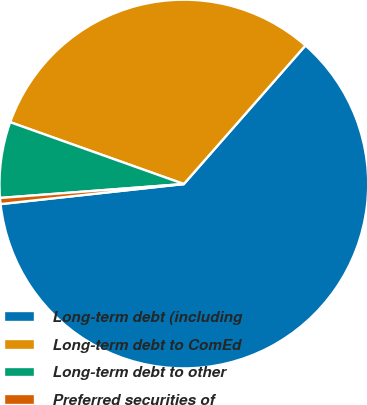Convert chart. <chart><loc_0><loc_0><loc_500><loc_500><pie_chart><fcel>Long-term debt (including<fcel>Long-term debt to ComEd<fcel>Long-term debt to other<fcel>Preferred securities of<nl><fcel>61.8%<fcel>31.02%<fcel>6.65%<fcel>0.53%<nl></chart> 